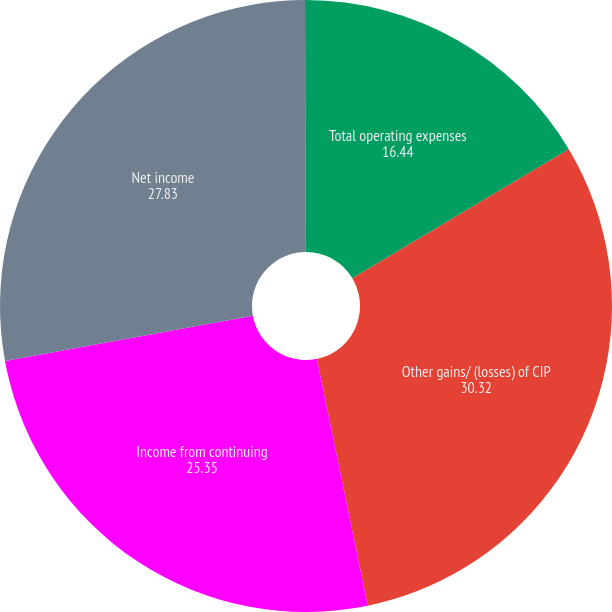Convert chart. <chart><loc_0><loc_0><loc_500><loc_500><pie_chart><fcel>Total operating expenses<fcel>Other gains/ (losses) of CIP<fcel>Income from continuing<fcel>Net income<fcel>Net income attributable to<nl><fcel>16.44%<fcel>30.32%<fcel>25.35%<fcel>27.83%<fcel>0.05%<nl></chart> 